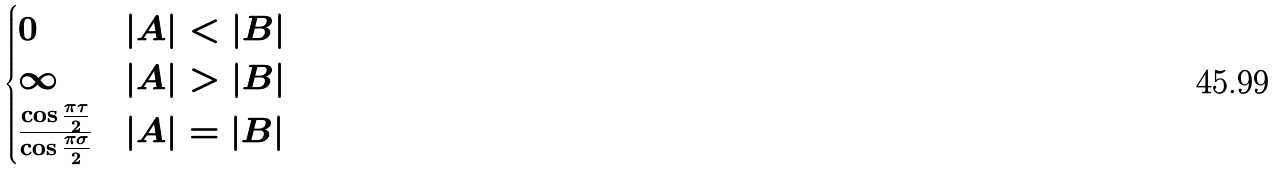Convert formula to latex. <formula><loc_0><loc_0><loc_500><loc_500>\begin{cases} 0 & | A | < | B | \\ \infty & | A | > | B | \\ \frac { \cos \frac { \pi \tau } { 2 } } { \cos \frac { \pi \sigma } { 2 } } & | A | = | B | \end{cases}</formula> 